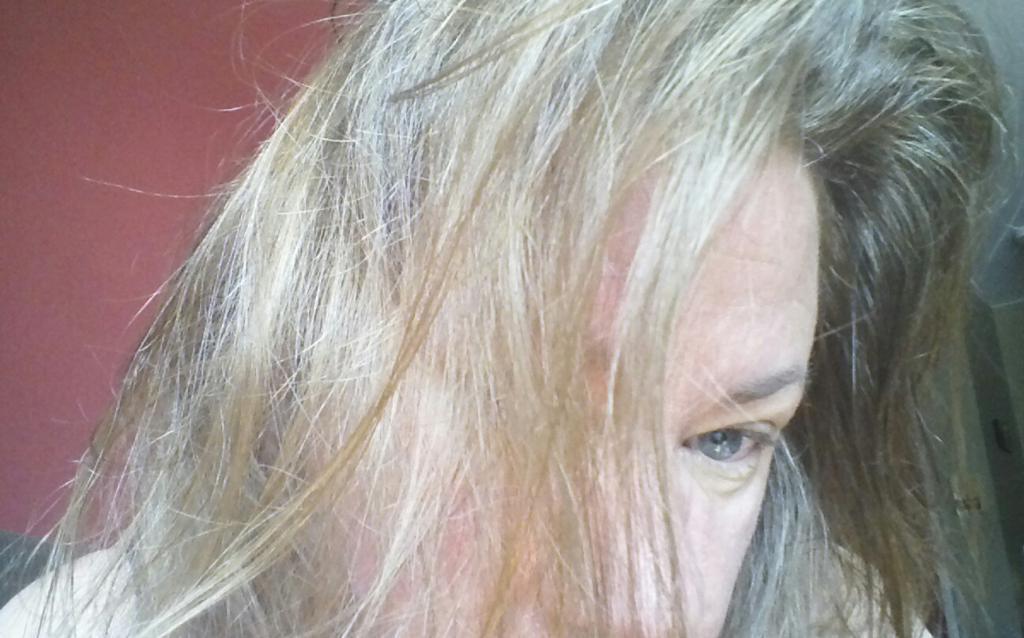Could you give a brief overview of what you see in this image? In this image, I can see a person with a hair, which is black and white in color. The background is maroon in color. 